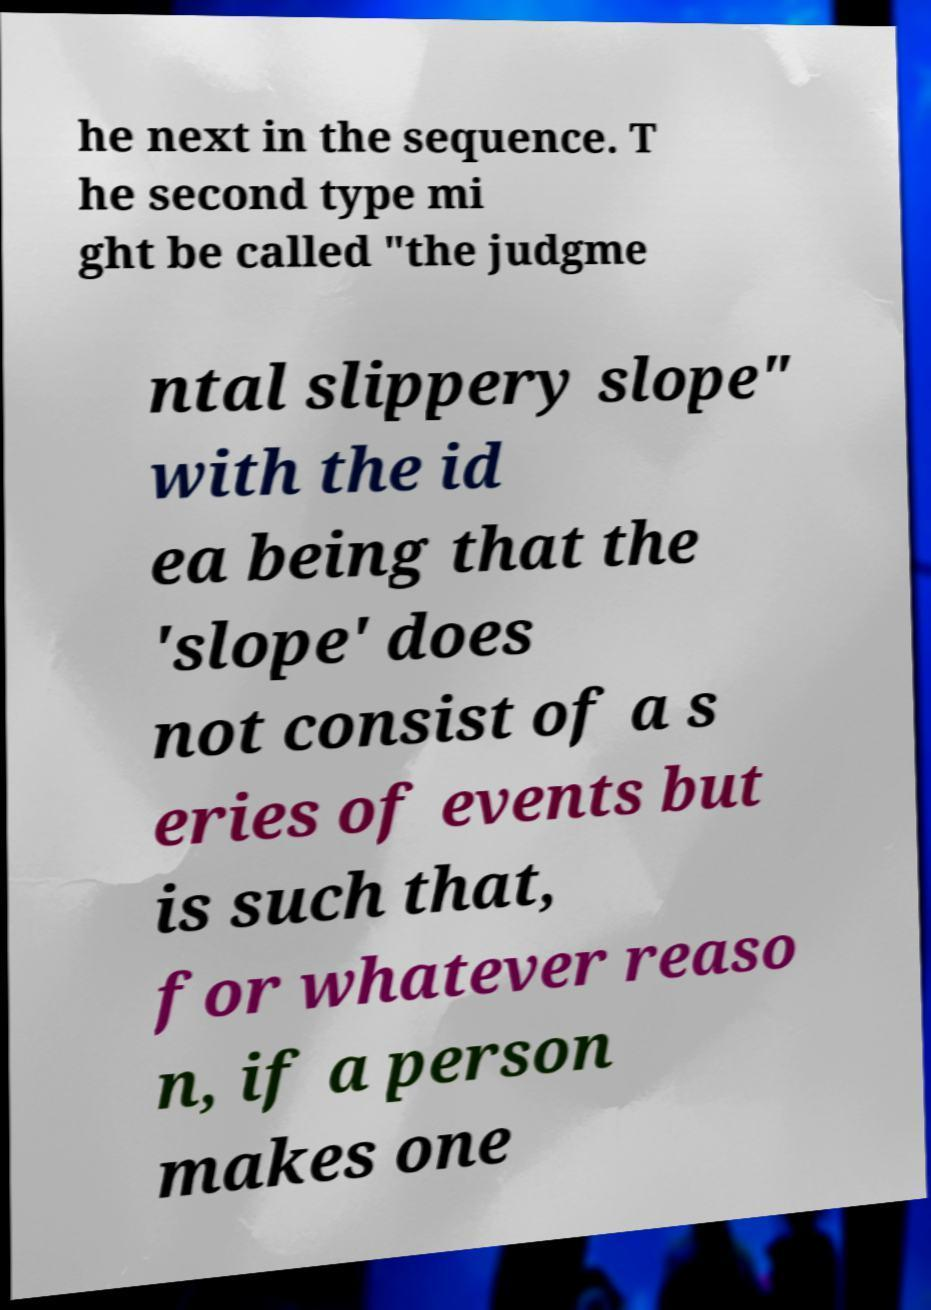Can you accurately transcribe the text from the provided image for me? he next in the sequence. T he second type mi ght be called "the judgme ntal slippery slope" with the id ea being that the 'slope' does not consist of a s eries of events but is such that, for whatever reaso n, if a person makes one 